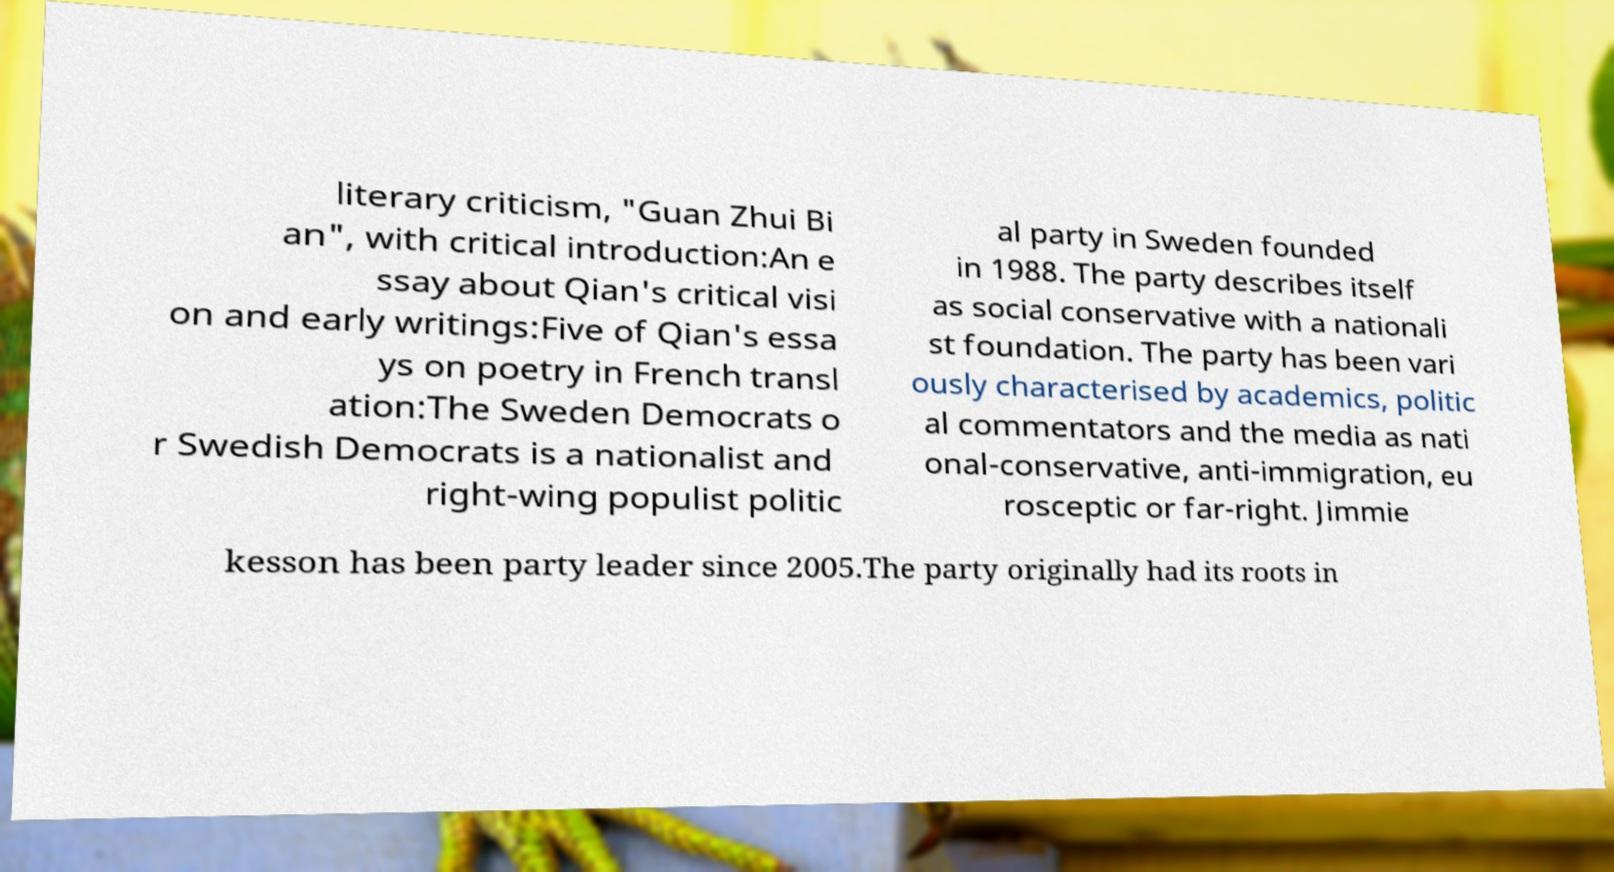Please identify and transcribe the text found in this image. literary criticism, "Guan Zhui Bi an", with critical introduction:An e ssay about Qian's critical visi on and early writings:Five of Qian's essa ys on poetry in French transl ation:The Sweden Democrats o r Swedish Democrats is a nationalist and right-wing populist politic al party in Sweden founded in 1988. The party describes itself as social conservative with a nationali st foundation. The party has been vari ously characterised by academics, politic al commentators and the media as nati onal-conservative, anti-immigration, eu rosceptic or far-right. Jimmie kesson has been party leader since 2005.The party originally had its roots in 